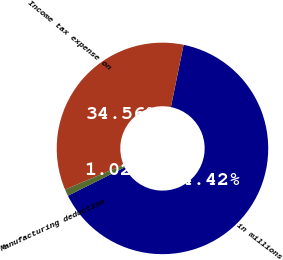<chart> <loc_0><loc_0><loc_500><loc_500><pie_chart><fcel>in millions<fcel>Income tax expense on<fcel>Manufacturing deduction<nl><fcel>64.41%<fcel>34.56%<fcel>1.02%<nl></chart> 